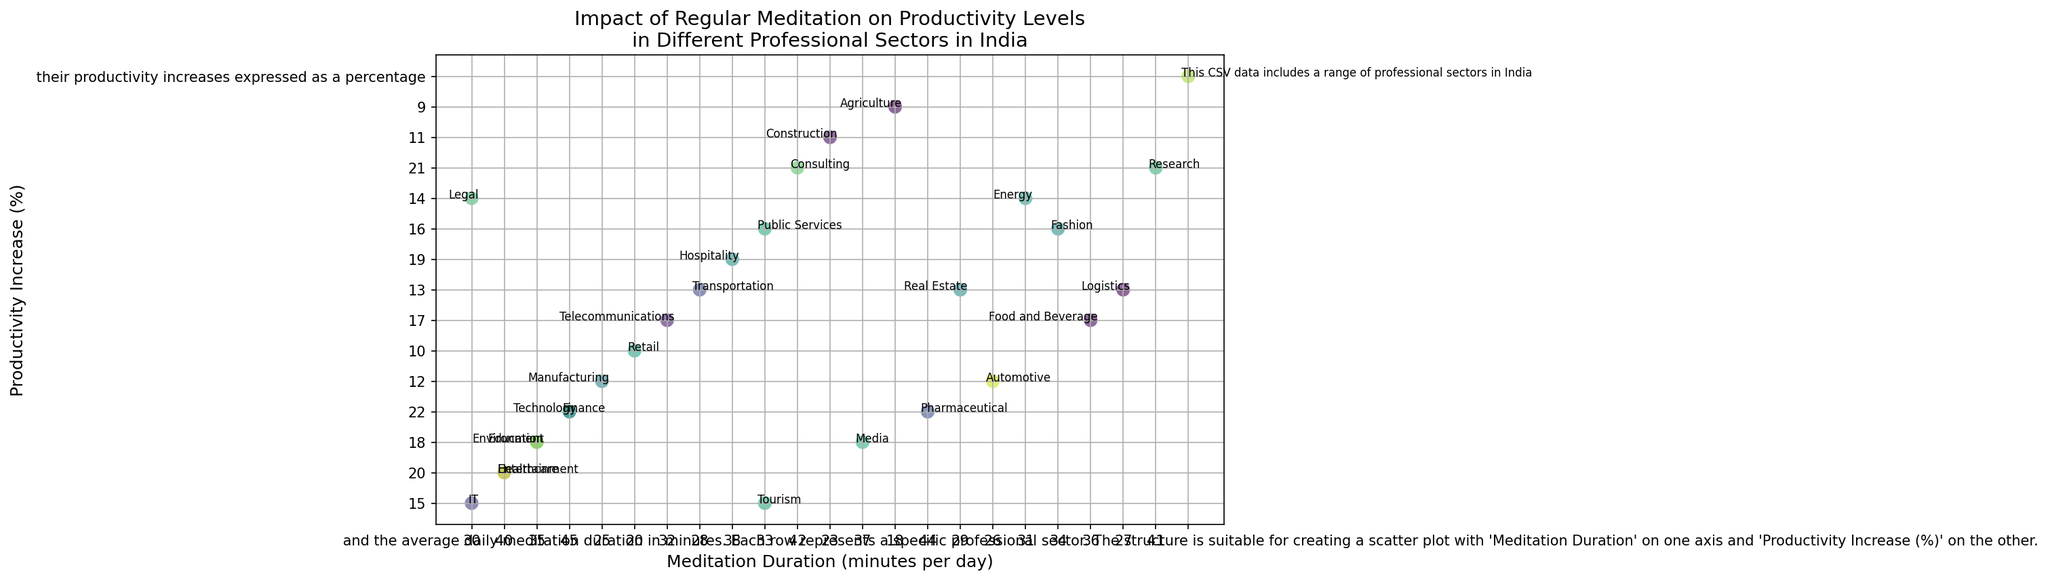What sector has the highest productivity increase? The plot shows that the Finance, Pharmaceutical, and Technology sectors have the highest productivity increase, each with a productivity increase of 22%. Identifying the highest point on the Y-axis (Productivity Increase) and checking the associated label confirms this.
Answer: Finance, Pharmaceutical, Technology Which sector has the lowest meditation duration? The plot indicates that the Agriculture sector has the lowest meditation duration at 18 minutes per day. By locating the point with the lowest value on the X-axis (Meditation Duration) and checking the associated label, this can be confirmed.
Answer: Agriculture Is there a sector where the productivity increase is exactly 20%? If so, which one? Yes, the plot shows Healthcare, Entertainment, and Logistics sectors with a productivity increase of exactly 20%. By looking at the points on the Y-axis corresponding to 20% and checking their labels, we can identify these sectors.
Answer: Healthcare, Entertainment How many sectors have a productivity increase greater than 20%? The plot reveals that there are six sectors with a productivity increase greater than 20%. Specifically, Finance, Pharmaceutical, Technology, and Consulting sectors meet this criterion. By counting the number of points above the 20% mark on the Y-axis and checking their labels, this can be identified.
Answer: 6 sectors What's the difference in meditation duration between the sectors with the highest and lowest productivity increase? The lowest productivity increase is observed in Agriculture (9%), with a meditation duration of 18 minutes, while the highest productivity increase is observed in Finance, Pharmaceutical, and Technology (22%), with meditation durations of 45 minutes. The difference is 45 - 18 = 27 minutes.
Answer: 27 minutes Do Education and Environment sectors have similar productivity increases and meditation durations? By examining the plot, both Education and Environment have a productivity increase of 18%. Their meditation durations are also similar, with Education at 35 minutes and Environment also at 35 minutes. This can be confirmed by locating their points on the plot and comparing the X and Y coordinates.
Answer: Yes Which sector located in the plot's middle has a roughly equal productivity increase and meditation duration? The Telecommunications sector sits near the middle of the plot and has a productivity increase close to 17% and a meditation duration around 32 minutes. This can be confirmed by identifying the plotted point near the center of the graph.
Answer: Telecommunications Compare the productivity increase of the Retail and Hospitality sectors. Which one is higher? The plot shows that the Hospitality sector has a productivity increase of 19%, while the Retail sector has 10%. By checking the points associated with these sectors on the Y-axis, it is clear that Hospitality has a higher productivity increase.
Answer: Hospitality What is the average meditation duration for sectors with at least a 20% productivity increase? The sectors with at least a 20% productivity increase are Finance, Pharmaceutical, Technology, Consulting, Healthcare, and Entertainment. Their meditation durations are 45, 44, 45, 42, 40, and 40 minutes respectively. The average is (45 + 44 + 45 + 42 + 40 + 40) / 6 = 256 / 6 ≈ 42.67 minutes.
Answer: 42.67 minutes 